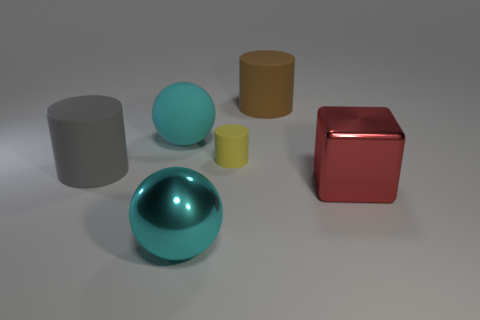There is another cyan object that is the same shape as the cyan matte thing; what is it made of?
Give a very brief answer. Metal. How many other things are the same size as the brown object?
Offer a very short reply. 4. There is a cyan thing behind the gray rubber object on the left side of the large shiny thing left of the tiny matte thing; what is its shape?
Provide a succinct answer. Sphere. The large thing that is right of the metallic ball and behind the big block has what shape?
Provide a short and direct response. Cylinder. How many things are green rubber blocks or large brown things that are right of the big gray cylinder?
Offer a very short reply. 1. Are the brown cylinder and the big red object made of the same material?
Your answer should be compact. No. How many other things are the same shape as the cyan matte object?
Give a very brief answer. 1. There is a matte object that is on the left side of the small yellow rubber object and in front of the cyan rubber object; how big is it?
Give a very brief answer. Large. What number of metallic objects are either small balls or brown things?
Provide a short and direct response. 0. Does the cyan rubber object that is behind the gray rubber cylinder have the same shape as the shiny object that is to the left of the tiny rubber cylinder?
Your answer should be very brief. Yes. 